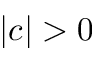<formula> <loc_0><loc_0><loc_500><loc_500>| c | > 0</formula> 